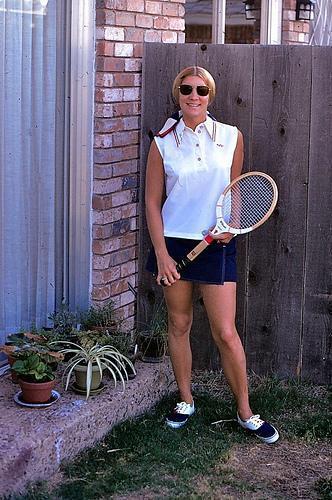How many people in the picture?
Give a very brief answer. 1. 